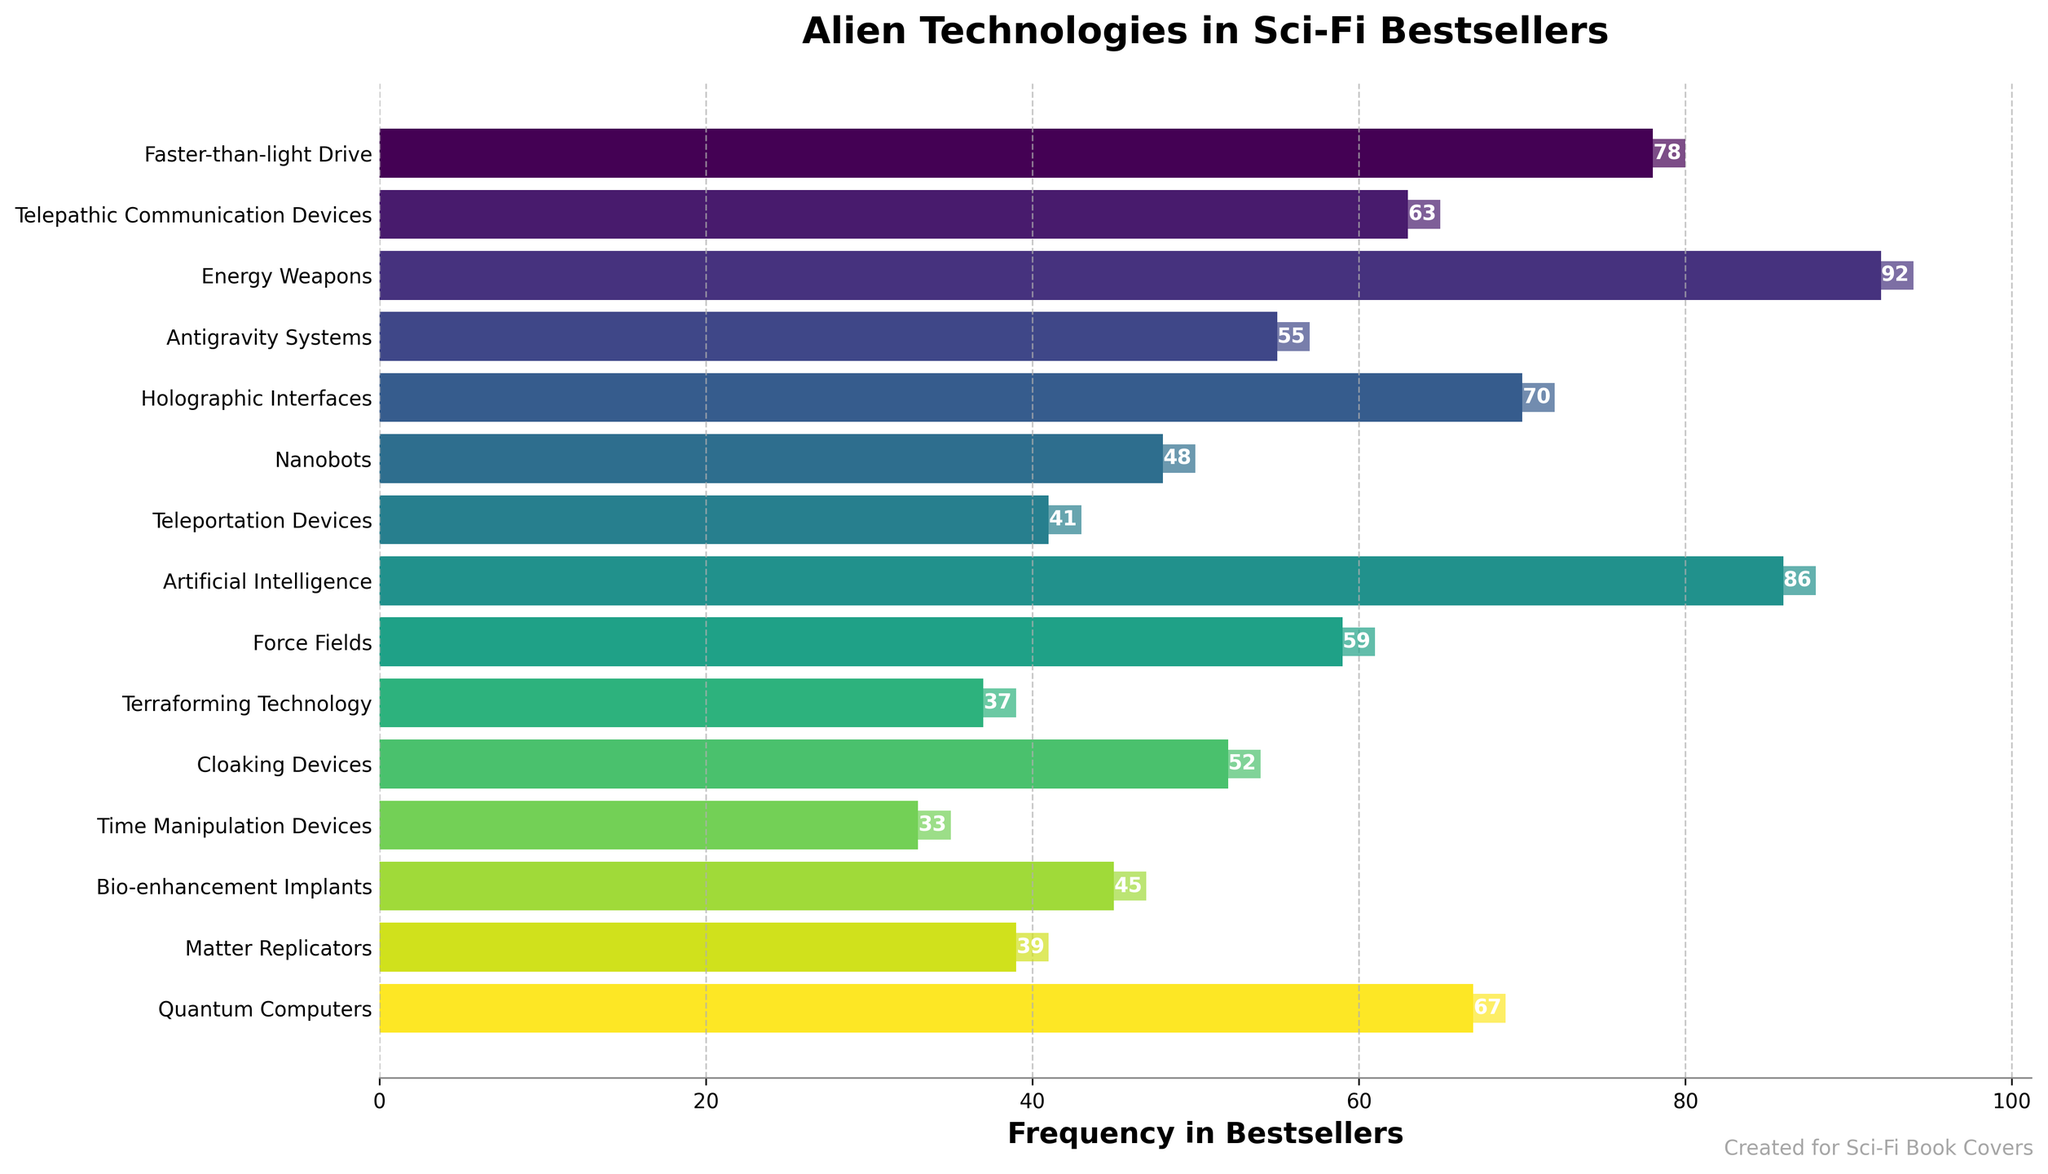How many more times are Energy Weapons featured compared to Time Manipulation Devices? First, find the frequency of Energy Weapons (92) and Time Manipulation Devices (33). Subtract the smaller value from the larger value: 92 - 33 = 59.
Answer: 59 Which alien technology is featured the least and how many times is it featured? Find the technology with the smallest frequency. Time Manipulation Devices have the lowest figure with a frequency of 33.
Answer: Time Manipulation Devices, 33 What is the sum of frequencies of Faster-than-light Drive and Artificial Intelligence? Add the frequencies of Faster-than-light Drive (78) and Artificial Intelligence (86). The sum is 78 + 86 = 164.
Answer: 164 Between Holographic Interfaces and Quantum Computers, which has a higher frequency and by how much? Quantum Computers have a frequency of 67, while Holographic Interfaces have a frequency of 70. Subtract the smaller value from the larger value: 70 - 67 = 3.
Answer: Holographic Interfaces, 3 What is the average frequency of all the telepathic-related technologies (Telepathic Communication Devices, Teleportation Devices, Cloaking Devices)? Sum the frequencies of the mentioned technologies: 63 (Telepathic Communication Devices) + 41 (Teleportation Devices) + 52 (Cloaking Devices). The sum is 156. Divide this by the number of technologies (3): 156 / 3 = 52.
Answer: 52 Which alien technology has the highest frequency, and what is that frequency? Identify the technology with the maximum frequency. Energy Weapons have the highest frequency of 92.
Answer: Energy Weapons, 92 Is the frequency of Nanobots more than the frequency of Bio-enhancement Implants? Compare the frequencies of Nanobots (48) and Bio-enhancement Implants (45). Since 48 > 45, the frequency of Nanobots is more.
Answer: Yes What are the combined frequencies of Antigravity Systems and Force Fields? Add the frequencies of Antigravity Systems (55) and Force Fields (59). The combined frequency is 55 + 59 = 114.
Answer: 114 If you sum up the frequencies of the three least featured technologies, what is that sum? Identify the three technologies with the lowest frequencies: Time Manipulation Devices (33), Terraforming Technology (37), and Matter Replicators (39). Sum these frequencies: 33 + 37 + 39 = 109.
Answer: 109 Between the frequencies of Faster-than-light Drive and Teleportation Devices, how many more times is the former featured than the latter? Compare the frequencies of Faster-than-light Drive (78) and Teleportation Devices (41). Subtract the smaller value from the larger value: 78 - 41 = 37.
Answer: 37 